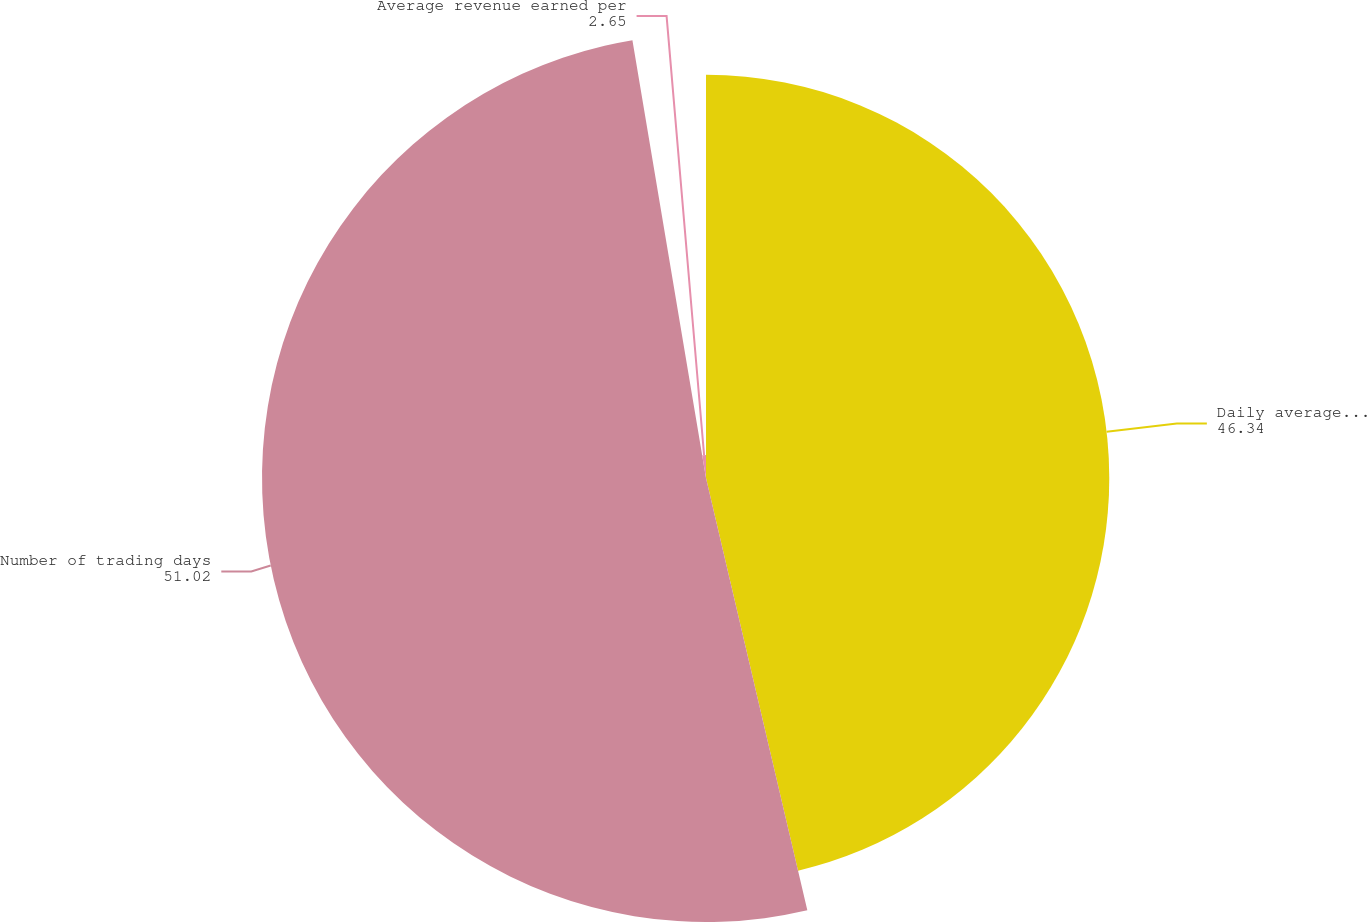Convert chart to OTSL. <chart><loc_0><loc_0><loc_500><loc_500><pie_chart><fcel>Daily average revenue trades<fcel>Number of trading days<fcel>Average revenue earned per<nl><fcel>46.34%<fcel>51.02%<fcel>2.65%<nl></chart> 